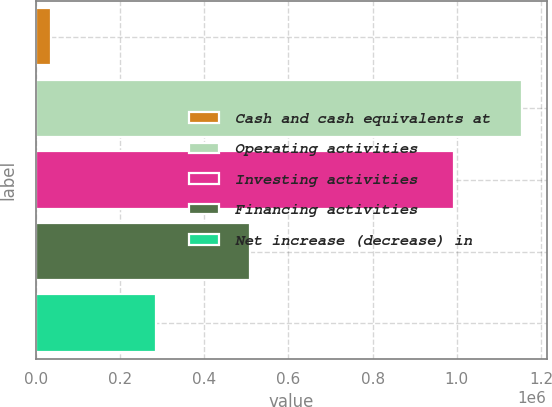<chart> <loc_0><loc_0><loc_500><loc_500><bar_chart><fcel>Cash and cash equivalents at<fcel>Operating activities<fcel>Investing activities<fcel>Financing activities<fcel>Net increase (decrease) in<nl><fcel>35102<fcel>1.15552e+06<fcel>994208<fcel>509497<fcel>285414<nl></chart> 